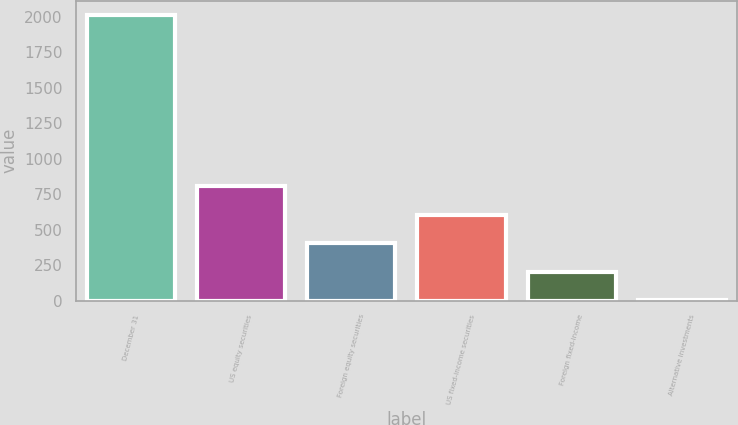Convert chart. <chart><loc_0><loc_0><loc_500><loc_500><bar_chart><fcel>December 31<fcel>US equity securities<fcel>Foreign equity securities<fcel>US fixed-income securities<fcel>Foreign fixed-income<fcel>Alternative investments<nl><fcel>2015<fcel>807.2<fcel>404.6<fcel>605.9<fcel>203.3<fcel>2<nl></chart> 